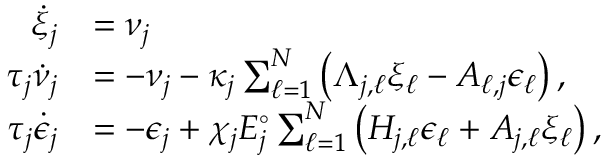Convert formula to latex. <formula><loc_0><loc_0><loc_500><loc_500>\begin{array} { r l } { \dot { \xi } _ { j } } & { = \nu _ { j } } \\ { \tau _ { j } \dot { \nu } _ { j } } & { = - \nu _ { j } - \kappa _ { j } \sum _ { \ell = 1 } ^ { N } \left ( \Lambda _ { j , \ell } \xi _ { \ell } - A _ { \ell , j } \epsilon _ { \ell } \right ) , } \\ { \tau _ { j } \dot { \epsilon } _ { j } } & { = - \epsilon _ { j } + \chi _ { j } E _ { j } ^ { \circ } \sum _ { \ell = 1 } ^ { N } \left ( H _ { j , \ell } \epsilon _ { \ell } + A _ { j , \ell } \xi _ { \ell } \right ) , } \end{array}</formula> 